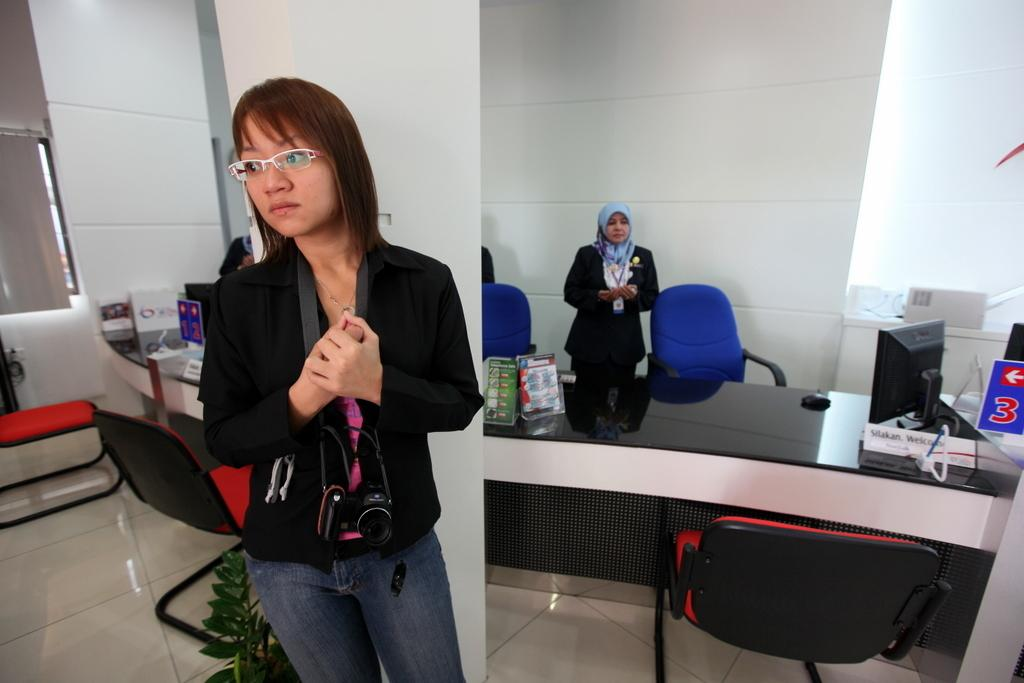What type of furniture is present in the image? There are chairs in the image. What are the people in the image doing? There are people standing on the floor in the image. What electronic device is visible in the image? There is a monitor in the image. What else can be seen on the floor in the image? There are other objects on the floor in the image. What type of texture do the snails have in the image? There are no snails present in the image, so we cannot determine their texture. How do the people in the image show respect to each other? The image does not provide information about the people's interactions or expressions of respect. 